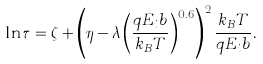<formula> <loc_0><loc_0><loc_500><loc_500>\ln \tau = \zeta + \left ( \eta - \lambda \left ( \frac { q E _ { i } b } { k _ { B } T } \right ) ^ { 0 . 6 } \right ) ^ { 2 } \frac { k _ { B } T } { q E _ { i } b } .</formula> 